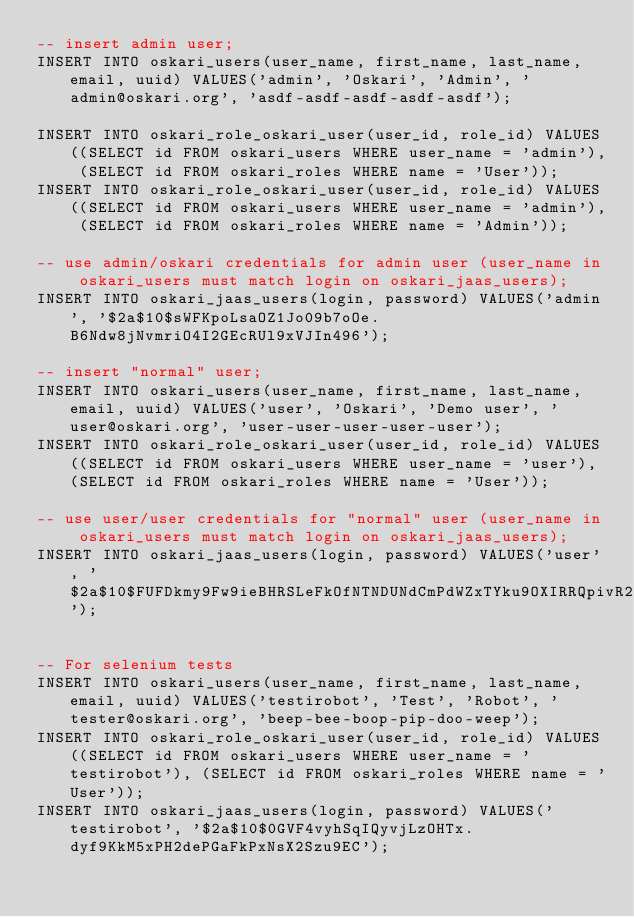<code> <loc_0><loc_0><loc_500><loc_500><_SQL_>-- insert admin user;
INSERT INTO oskari_users(user_name, first_name, last_name, email, uuid) VALUES('admin', 'Oskari', 'Admin', 'admin@oskari.org', 'asdf-asdf-asdf-asdf-asdf');

INSERT INTO oskari_role_oskari_user(user_id, role_id) VALUES((SELECT id FROM oskari_users WHERE user_name = 'admin'), (SELECT id FROM oskari_roles WHERE name = 'User'));
INSERT INTO oskari_role_oskari_user(user_id, role_id) VALUES((SELECT id FROM oskari_users WHERE user_name = 'admin'), (SELECT id FROM oskari_roles WHERE name = 'Admin'));

-- use admin/oskari credentials for admin user (user_name in oskari_users must match login on oskari_jaas_users);
INSERT INTO oskari_jaas_users(login, password) VALUES('admin', '$2a$10$sWFKpoLsaOZ1Jo09b7oOe.B6Ndw8jNvmriO4I2GEcRUl9xVJIn496');

-- insert "normal" user;
INSERT INTO oskari_users(user_name, first_name, last_name, email, uuid) VALUES('user', 'Oskari', 'Demo user', 'user@oskari.org', 'user-user-user-user-user');
INSERT INTO oskari_role_oskari_user(user_id, role_id) VALUES((SELECT id FROM oskari_users WHERE user_name = 'user'), (SELECT id FROM oskari_roles WHERE name = 'User'));

-- use user/user credentials for "normal" user (user_name in oskari_users must match login on oskari_jaas_users);
INSERT INTO oskari_jaas_users(login, password) VALUES('user', '$2a$10$FUFDkmy9Fw9ieBHRSLeFkOfNTNDUNdCmPdWZxTYku9OXIRRQpivR2');


-- For selenium tests
INSERT INTO oskari_users(user_name, first_name, last_name, email, uuid) VALUES('testirobot', 'Test', 'Robot', 'tester@oskari.org', 'beep-bee-boop-pip-doo-weep');
INSERT INTO oskari_role_oskari_user(user_id, role_id) VALUES((SELECT id FROM oskari_users WHERE user_name = 'testirobot'), (SELECT id FROM oskari_roles WHERE name = 'User'));
INSERT INTO oskari_jaas_users(login, password) VALUES('testirobot', '$2a$10$0GVF4vyhSqIQyvjLzOHTx.dyf9KkM5xPH2dePGaFkPxNsX2Szu9EC');
</code> 